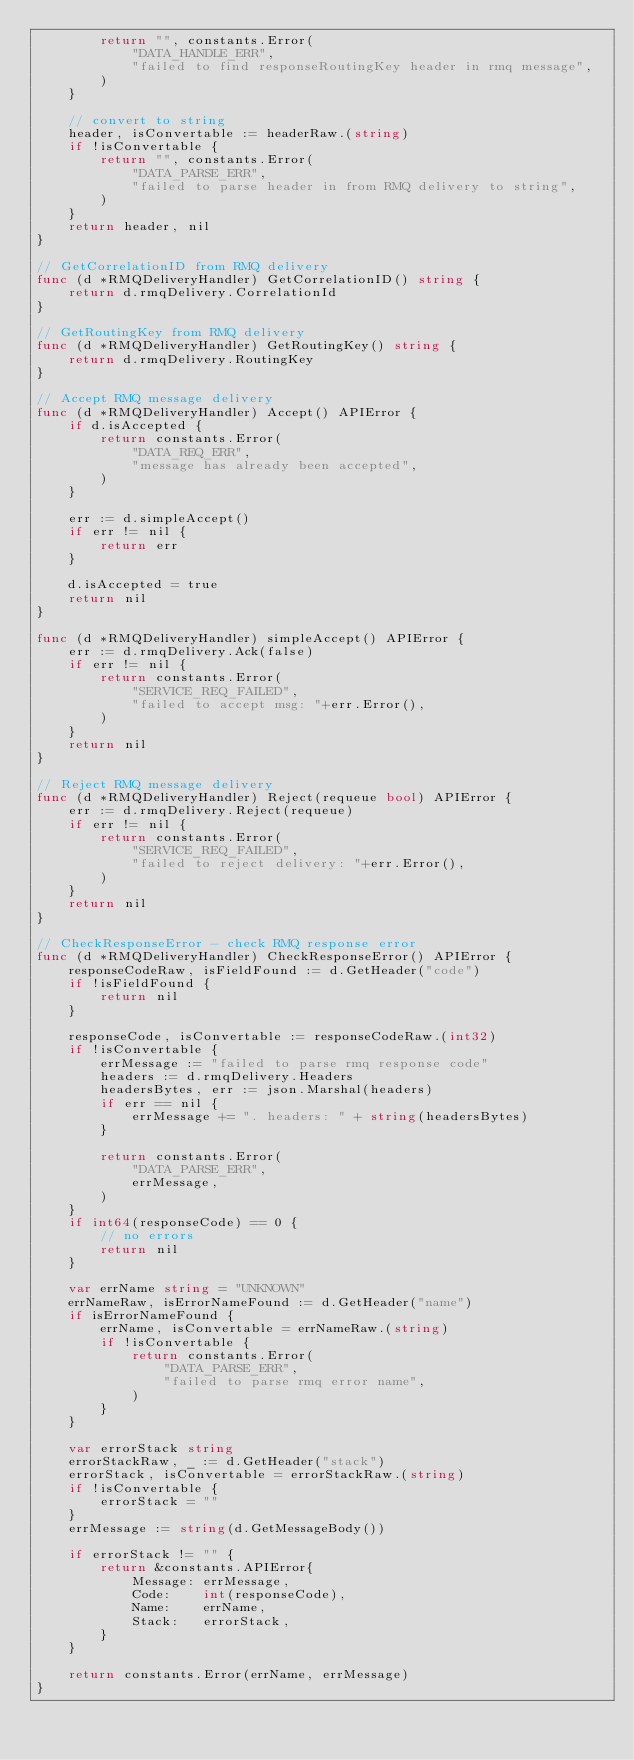Convert code to text. <code><loc_0><loc_0><loc_500><loc_500><_Go_>		return "", constants.Error(
			"DATA_HANDLE_ERR",
			"failed to find responseRoutingKey header in rmq message",
		)
	}

	// convert to string
	header, isConvertable := headerRaw.(string)
	if !isConvertable {
		return "", constants.Error(
			"DATA_PARSE_ERR",
			"failed to parse header in from RMQ delivery to string",
		)
	}
	return header, nil
}

// GetCorrelationID from RMQ delivery
func (d *RMQDeliveryHandler) GetCorrelationID() string {
	return d.rmqDelivery.CorrelationId
}

// GetRoutingKey from RMQ delivery
func (d *RMQDeliveryHandler) GetRoutingKey() string {
	return d.rmqDelivery.RoutingKey
}

// Accept RMQ message delivery
func (d *RMQDeliveryHandler) Accept() APIError {
	if d.isAccepted {
		return constants.Error(
			"DATA_REQ_ERR",
			"message has already been accepted",
		)
	}

	err := d.simpleAccept()
	if err != nil {
		return err
	}

	d.isAccepted = true
	return nil
}

func (d *RMQDeliveryHandler) simpleAccept() APIError {
	err := d.rmqDelivery.Ack(false)
	if err != nil {
		return constants.Error(
			"SERVICE_REQ_FAILED",
			"failed to accept msg: "+err.Error(),
		)
	}
	return nil
}

// Reject RMQ message delivery
func (d *RMQDeliveryHandler) Reject(requeue bool) APIError {
	err := d.rmqDelivery.Reject(requeue)
	if err != nil {
		return constants.Error(
			"SERVICE_REQ_FAILED",
			"failed to reject delivery: "+err.Error(),
		)
	}
	return nil
}

// CheckResponseError - check RMQ response error
func (d *RMQDeliveryHandler) CheckResponseError() APIError {
	responseCodeRaw, isFieldFound := d.GetHeader("code")
	if !isFieldFound {
		return nil
	}

	responseCode, isConvertable := responseCodeRaw.(int32)
	if !isConvertable {
		errMessage := "failed to parse rmq response code"
		headers := d.rmqDelivery.Headers
		headersBytes, err := json.Marshal(headers)
		if err == nil {
			errMessage += ". headers: " + string(headersBytes)
		}

		return constants.Error(
			"DATA_PARSE_ERR",
			errMessage,
		)
	}
	if int64(responseCode) == 0 {
		// no errors
		return nil
	}

	var errName string = "UNKNOWN"
	errNameRaw, isErrorNameFound := d.GetHeader("name")
	if isErrorNameFound {
		errName, isConvertable = errNameRaw.(string)
		if !isConvertable {
			return constants.Error(
				"DATA_PARSE_ERR",
				"failed to parse rmq error name",
			)
		}
	}

	var errorStack string
	errorStackRaw, _ := d.GetHeader("stack")
	errorStack, isConvertable = errorStackRaw.(string)
	if !isConvertable {
		errorStack = ""
	}
	errMessage := string(d.GetMessageBody())

	if errorStack != "" {
		return &constants.APIError{
			Message: errMessage,
			Code:    int(responseCode),
			Name:    errName,
			Stack:   errorStack,
		}
	}

	return constants.Error(errName, errMessage)
}
</code> 